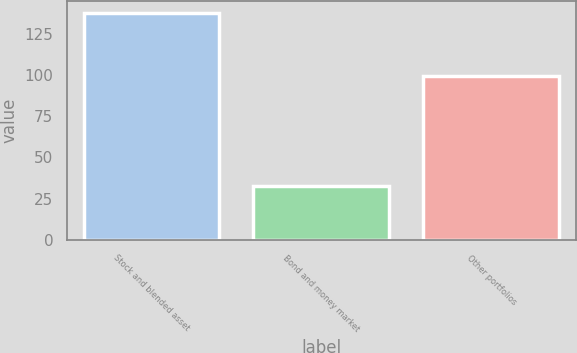Convert chart to OTSL. <chart><loc_0><loc_0><loc_500><loc_500><bar_chart><fcel>Stock and blended asset<fcel>Bond and money market<fcel>Other portfolios<nl><fcel>137.7<fcel>32.5<fcel>99.3<nl></chart> 